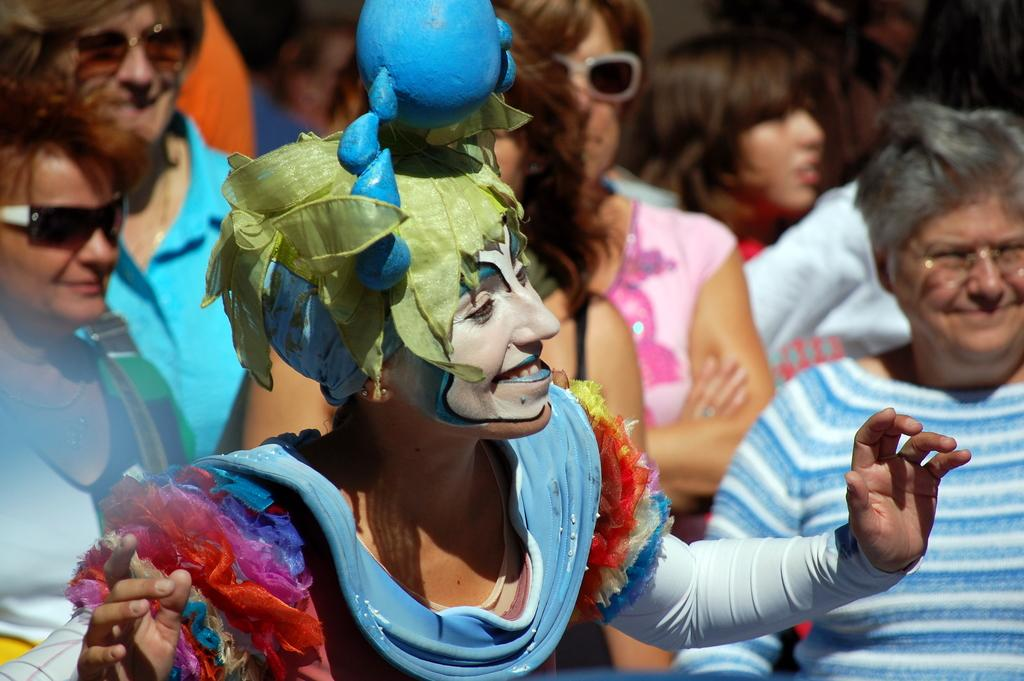What is the person in the image wearing? The person in the image is wearing a costume. What colors can be seen on the costume? The costume has blue, orange, pink, and green colors. Can you describe the setting of the image? There are other persons standing in the background of the image. What type of quince is being served at the historical event in the image? There is no mention of a quince or a historical event in the image. The image features a person wearing a costume with specific colors, and there are other persons standing in the background. 